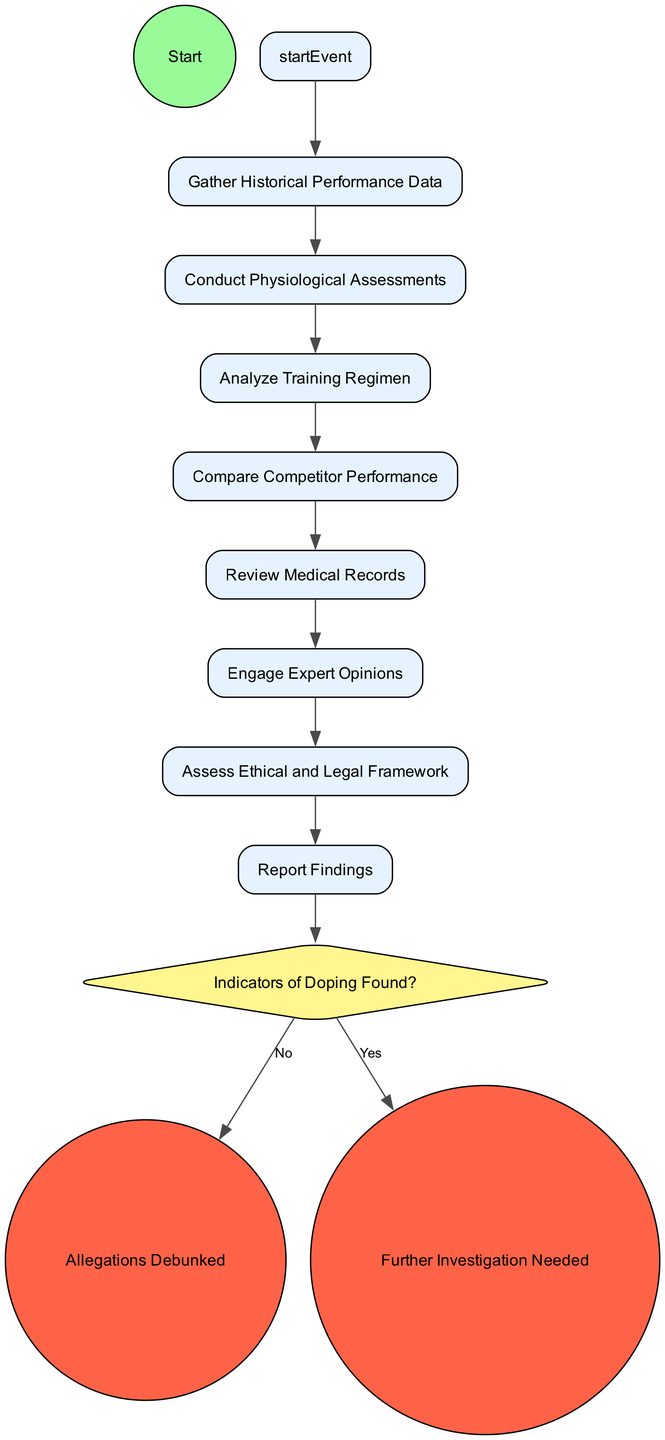What is the first activity in the diagram? The first activity is "Gather Historical Performance Data," which can be determined as it directly follows the Start event.
Answer: Gather Historical Performance Data How many activities are there in total? By counting the activities listed, there are a total of eight activities in the diagram.
Answer: 8 What is the last activity before the decision point? The last activity before the decision point is "Report Findings," as it is the activity that leads directly to the decision point from the final activity.
Answer: Report Findings What is the decision point called? The decision point is referred to as "Indicators of Doping Found?" which is highlighted in the diagram as a diamond-shaped node.
Answer: Indicators of Doping Found? If valid indicators of doping are found, what is the next step? If valid indicators of doping are found, the next step is to conclude with "Further Investigation Needed" as indicated by the transition leading from the decision point.
Answer: Further Investigation Needed How many end events are present in the diagram? There are two end events present in the diagram, both of which conclude the process based on the findings from the analysis.
Answer: 2 What activity follows the assessment of ethical and legal framework? The activity that follows the assessment of ethical and legal framework is "Report Findings," which comes next in the sequence of activities.
Answer: Report Findings What color is used to represent start and end events? The start event is colored green, and the end events are colored red, indicating their unique roles in the diagram flow.
Answer: Green and Red What does the decision point lead to if no indicators of doping are found? If no indicators of doping are found, the decision point leads to the end event "Allegations Debunked," thus concluding the analysis with a positive outcome.
Answer: Allegations Debunked 